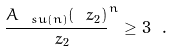Convert formula to latex. <formula><loc_0><loc_0><loc_500><loc_500>\frac { A _ { \ s u ( n ) } ( \ z _ { 2 } ) } { \ z _ { 2 } } ^ { n } \geq 3 \ .</formula> 